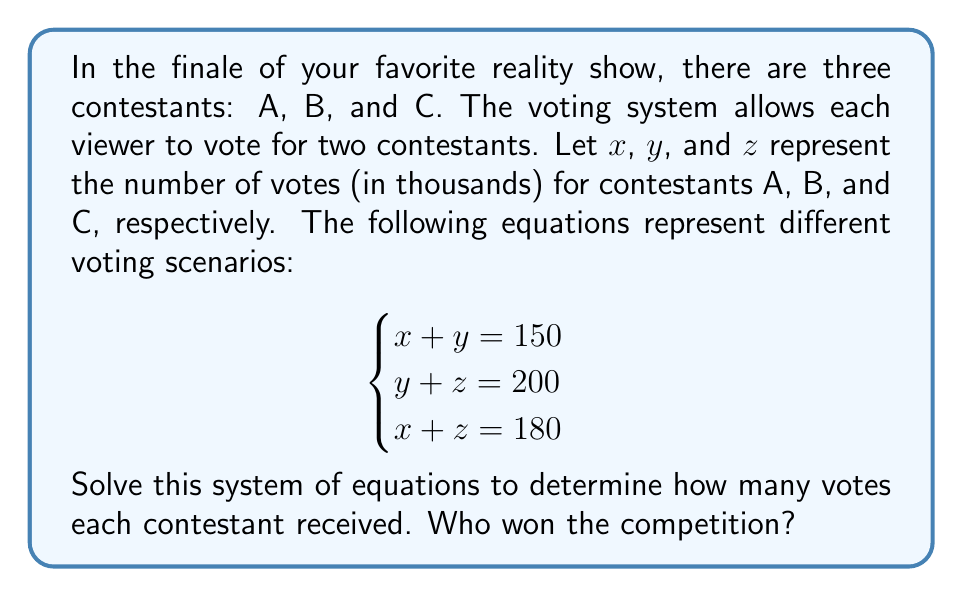Could you help me with this problem? Let's solve this system of equations step by step:

1) We have three equations:
   $$\begin{cases}
   x + y = 150 \quad (1)\\
   y + z = 200 \quad (2)\\
   x + z = 180 \quad (3)
   \end{cases}$$

2) Add equations (1) and (2):
   $$(x + y) + (y + z) = 150 + 200$$
   $$x + 2y + z = 350 \quad (4)$$

3) Subtract equation (3) from equation (4):
   $$(x + 2y + z) - (x + z) = 350 - 180$$
   $$2y = 170$$
   $$y = 85$$

4) Substitute $y = 85$ into equation (1):
   $$x + 85 = 150$$
   $$x = 65$$

5) Substitute $y = 85$ into equation (2):
   $$85 + z = 200$$
   $$z = 115$$

6) Verify the solution by substituting into equation (3):
   $$65 + 115 = 180$$
   $$180 = 180$$ (This checks out)

Therefore, the number of votes (in thousands) for each contestant is:
$x = 65$ (Contestant A)
$y = 85$ (Contestant B)
$z = 115$ (Contestant C)

Contestant C received the most votes and won the competition.
Answer: Contestant A: 65,000 votes
Contestant B: 85,000 votes
Contestant C: 115,000 votes

Contestant C won the competition. 